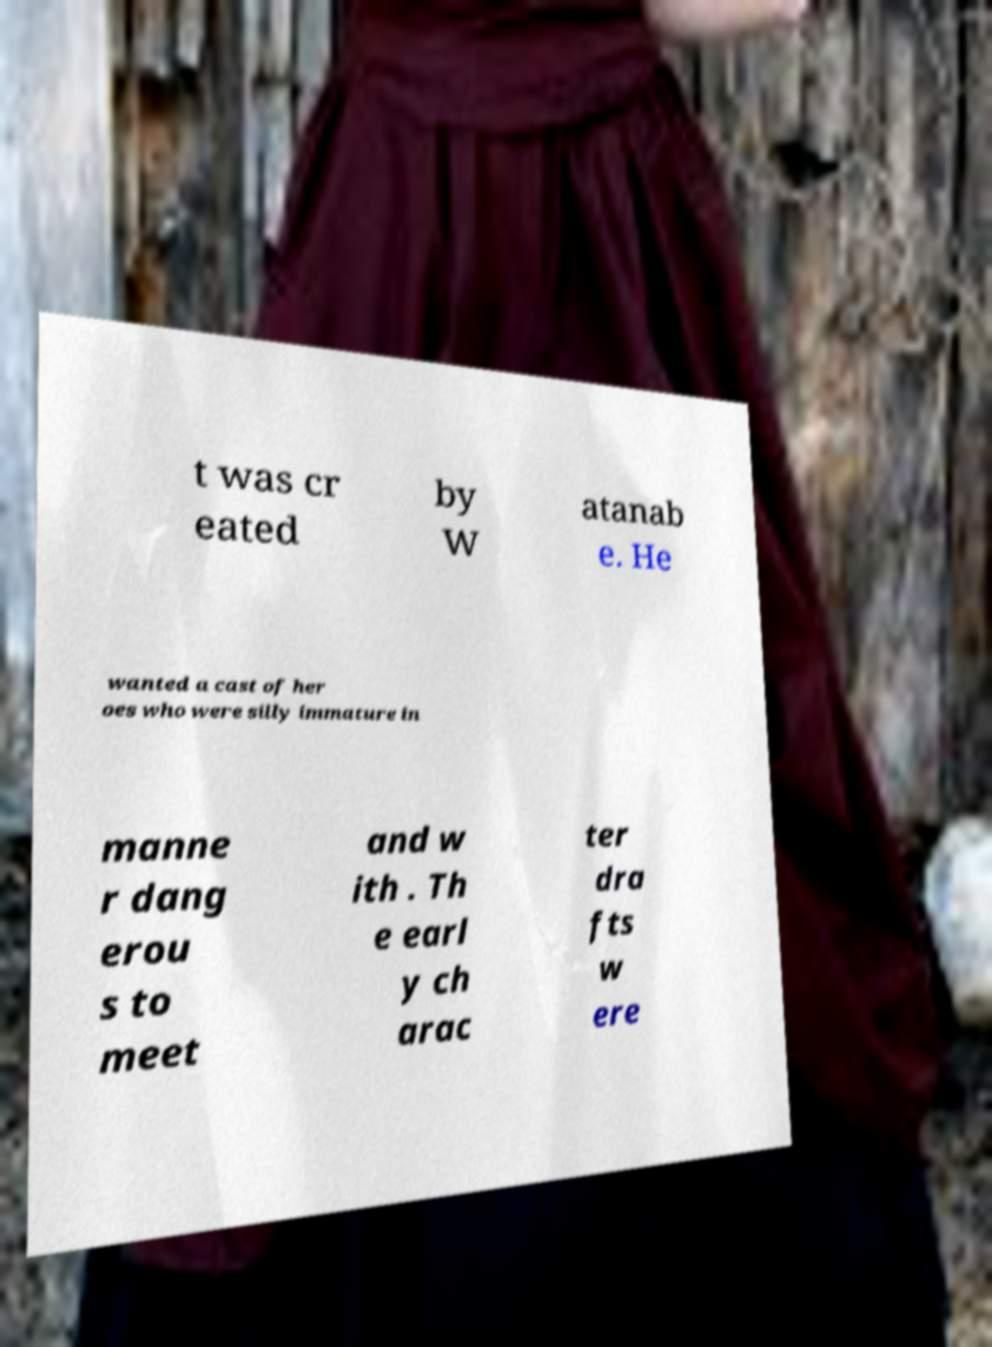I need the written content from this picture converted into text. Can you do that? t was cr eated by W atanab e. He wanted a cast of her oes who were silly immature in manne r dang erou s to meet and w ith . Th e earl y ch arac ter dra fts w ere 